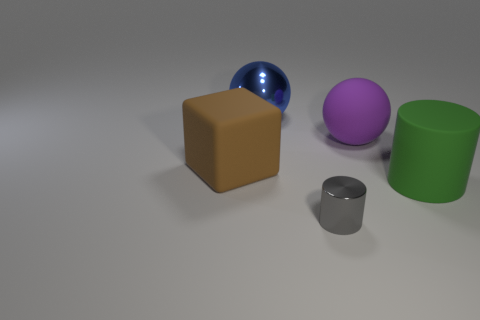Does the metallic object that is behind the green cylinder have the same shape as the purple thing?
Make the answer very short. Yes. Is the number of small metallic cylinders in front of the gray metal object less than the number of metal cylinders?
Your answer should be compact. Yes. Do the small gray object and the metal object that is behind the green matte cylinder have the same shape?
Keep it short and to the point. No. Is there a cylinder made of the same material as the brown object?
Offer a terse response. Yes. There is a object on the left side of the shiny thing that is behind the brown matte object; are there any tiny gray metallic things to the right of it?
Provide a succinct answer. Yes. How many other things are there of the same shape as the large brown rubber thing?
Offer a very short reply. 0. The rubber object to the left of the thing behind the sphere that is in front of the metal ball is what color?
Provide a short and direct response. Brown. What number of blue things are there?
Your answer should be compact. 1. How many small things are cylinders or green cylinders?
Offer a very short reply. 1. There is a green thing that is the same size as the matte cube; what is its shape?
Offer a terse response. Cylinder. 